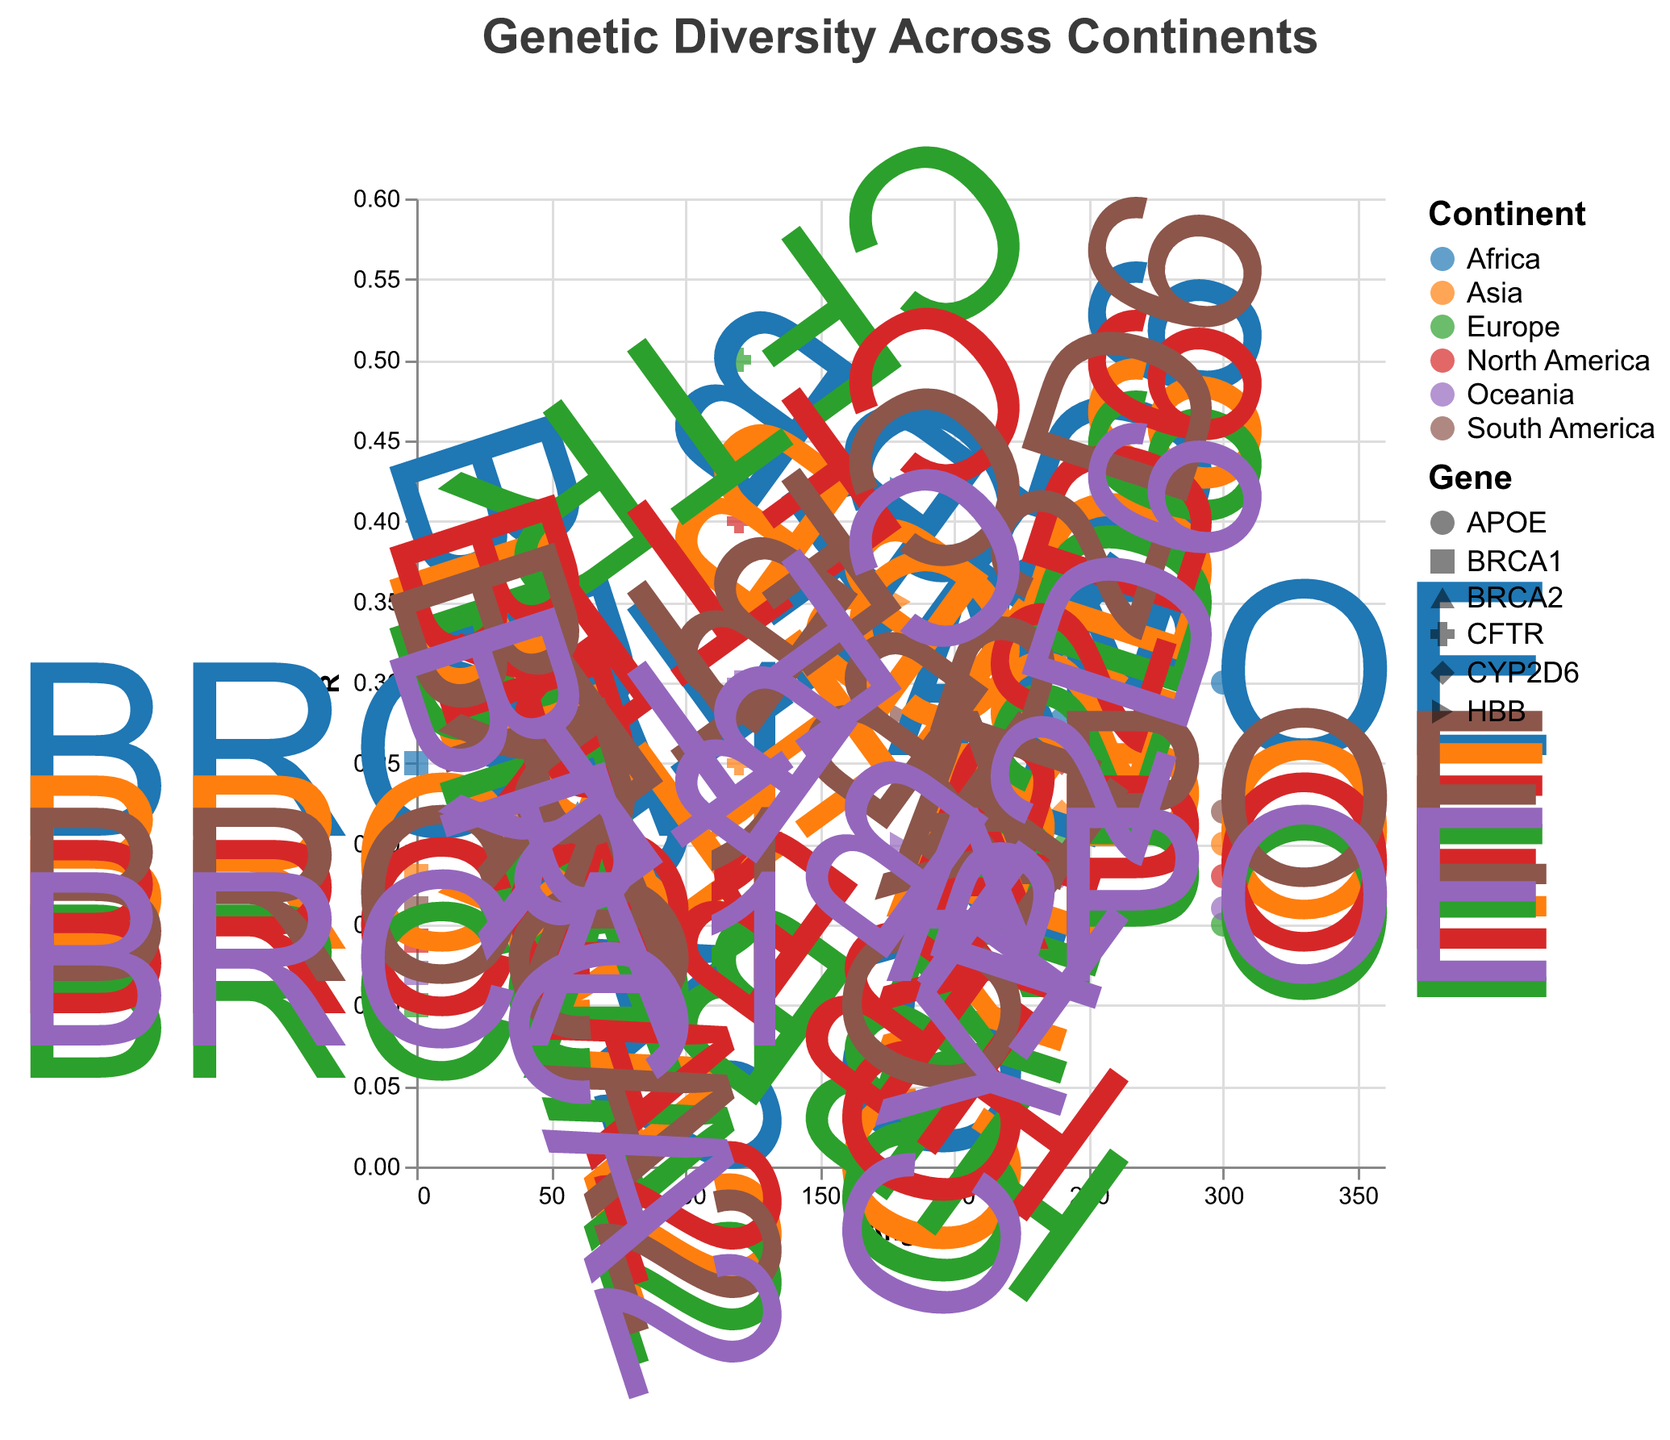What is the title of the chart? The title can be found at the top of the figure, indicating what the chart represents. In this case, it is "Genetic Diversity Across Continents".
Answer: Genetic Diversity Across Continents Which continent has the highest allele frequency for the CFTR gene? Look at the color corresponding to each continent and locate the data point for the CFTR gene at an angle of 120°. Compare the R values. Europe has the highest value at 0.50.
Answer: Europe How many genes are displayed in the polar scatter chart? Each unique shape represents a different gene. By counting the legend entries, we find: BRCA1, BRCA2, CFTR, HBB, CYP2D6, and APOE.
Answer: 6 Which continent has the lowest allele frequency for the HBB gene? Locate the data points for the HBB gene at an angle of 180° and compare the R values for each continent. Europe has the lowest value at 0.05.
Answer: Europe What is the average allele frequency of the BRCA1 gene across all continents? Sum the allele frequencies of BRCA1 for all continents and divide by the number of continents. (0.25 + 0.18 + 0.10 + 0.14 + 0.16 + 0.12) / 6 = 0.1583
Answer: 0.1583 Which gene shows the greatest diversity in allele frequency across continents? By inspecting the range of R values for each gene, we see CFTR ranges from 0.25 to 0.50, indicating the greatest diversity.
Answer: CFTR Do continents with higher diversity in one gene also show high diversity in another gene? Compare the allele frequencies of two different genes (e.g., CFTR and HBB) across continents to see if they both show high diversity. Both genes show variable allele frequencies across continents, suggesting variability in genetic diversity.
Answer: Yes Which gene has the equal allele frequency for both BRCA1 and BRCA2 in Oceania? Look at the data points for BRCA1 and BRCA2 in Oceania and compare their R values. Both have allele frequencies of BRCA1 (0.12) and BRCA2 (0.10).
Answer: None 